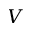<formula> <loc_0><loc_0><loc_500><loc_500>V</formula> 